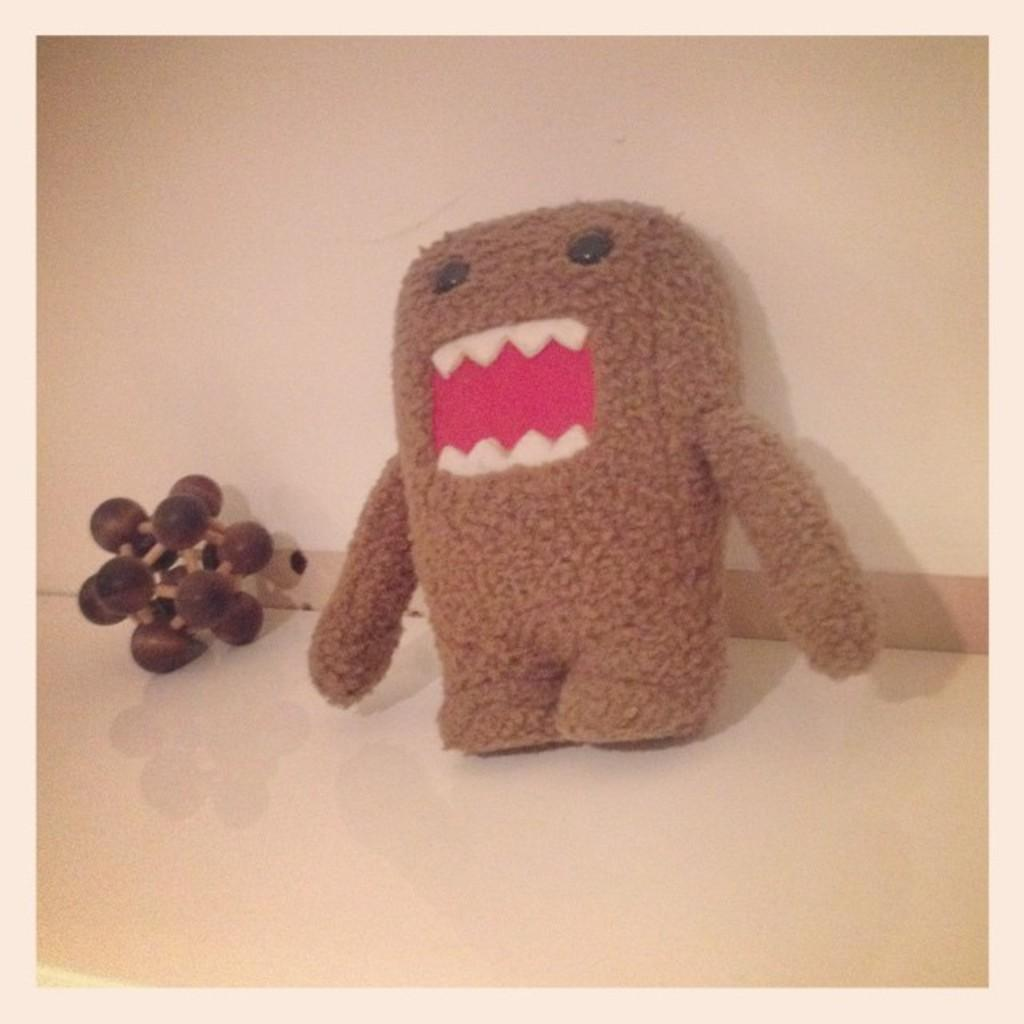What type of object can be seen in the image? There is a doll and a toy in the image. Where are the doll and toy located? The doll and toy are on a surface in the image. What can be seen in the background of the image? There is a wall visible in the background of the image. What time does the clock show in the image? There is no clock present in the image, so it is not possible to determine the time. 